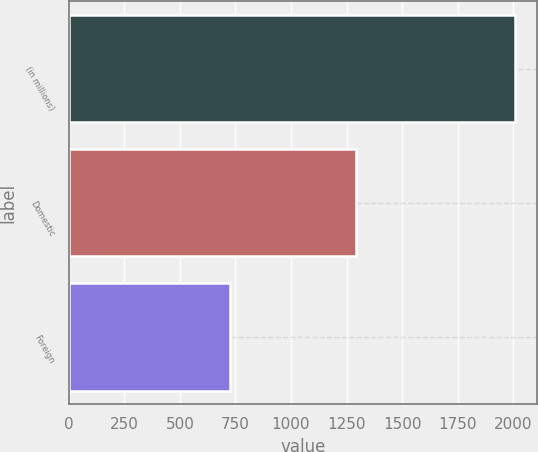Convert chart to OTSL. <chart><loc_0><loc_0><loc_500><loc_500><bar_chart><fcel>(in millions)<fcel>Domestic<fcel>Foreign<nl><fcel>2007<fcel>1294<fcel>725<nl></chart> 